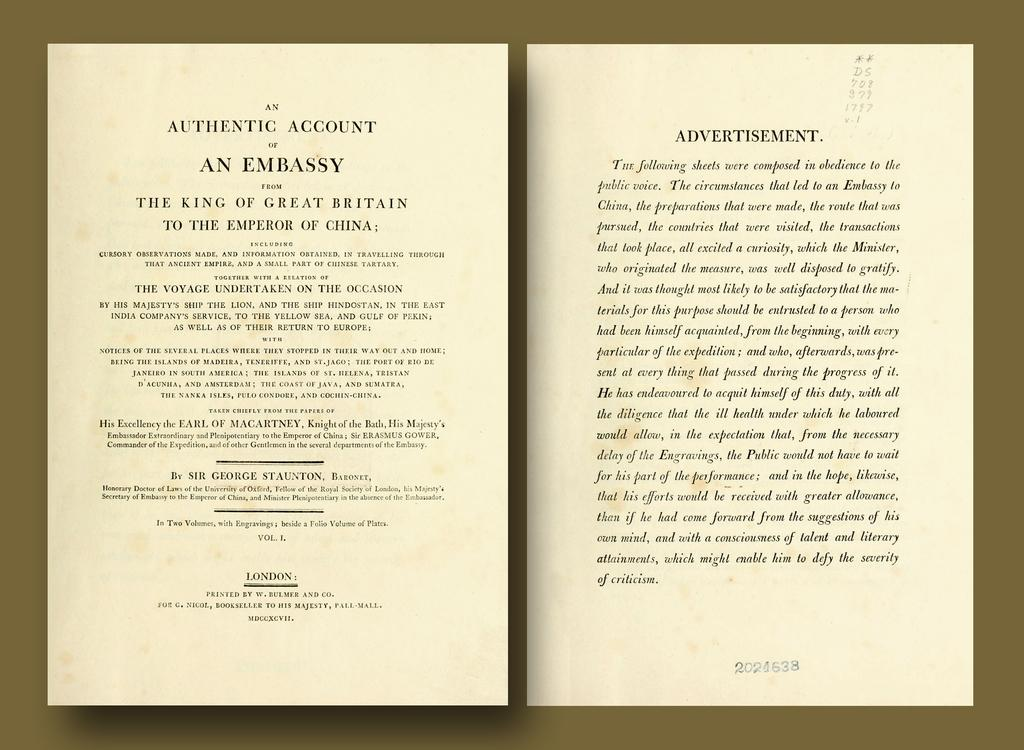<image>
Relay a brief, clear account of the picture shown. and open book that is called an authentic account of an embassy 